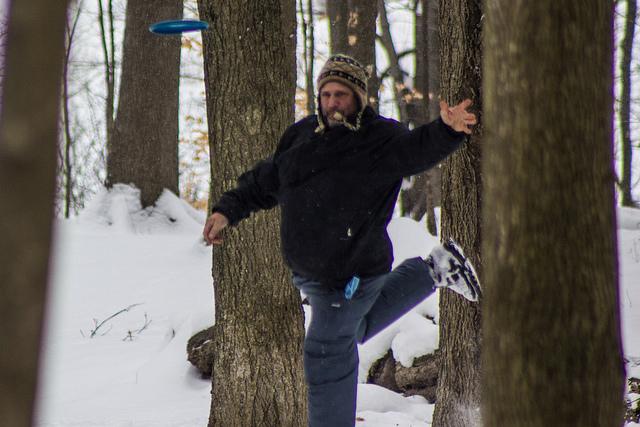Is this a forest?
Be succinct. Yes. What is the man throwing?
Keep it brief. Frisbee. Is both feet on the ground?
Quick response, please. No. 